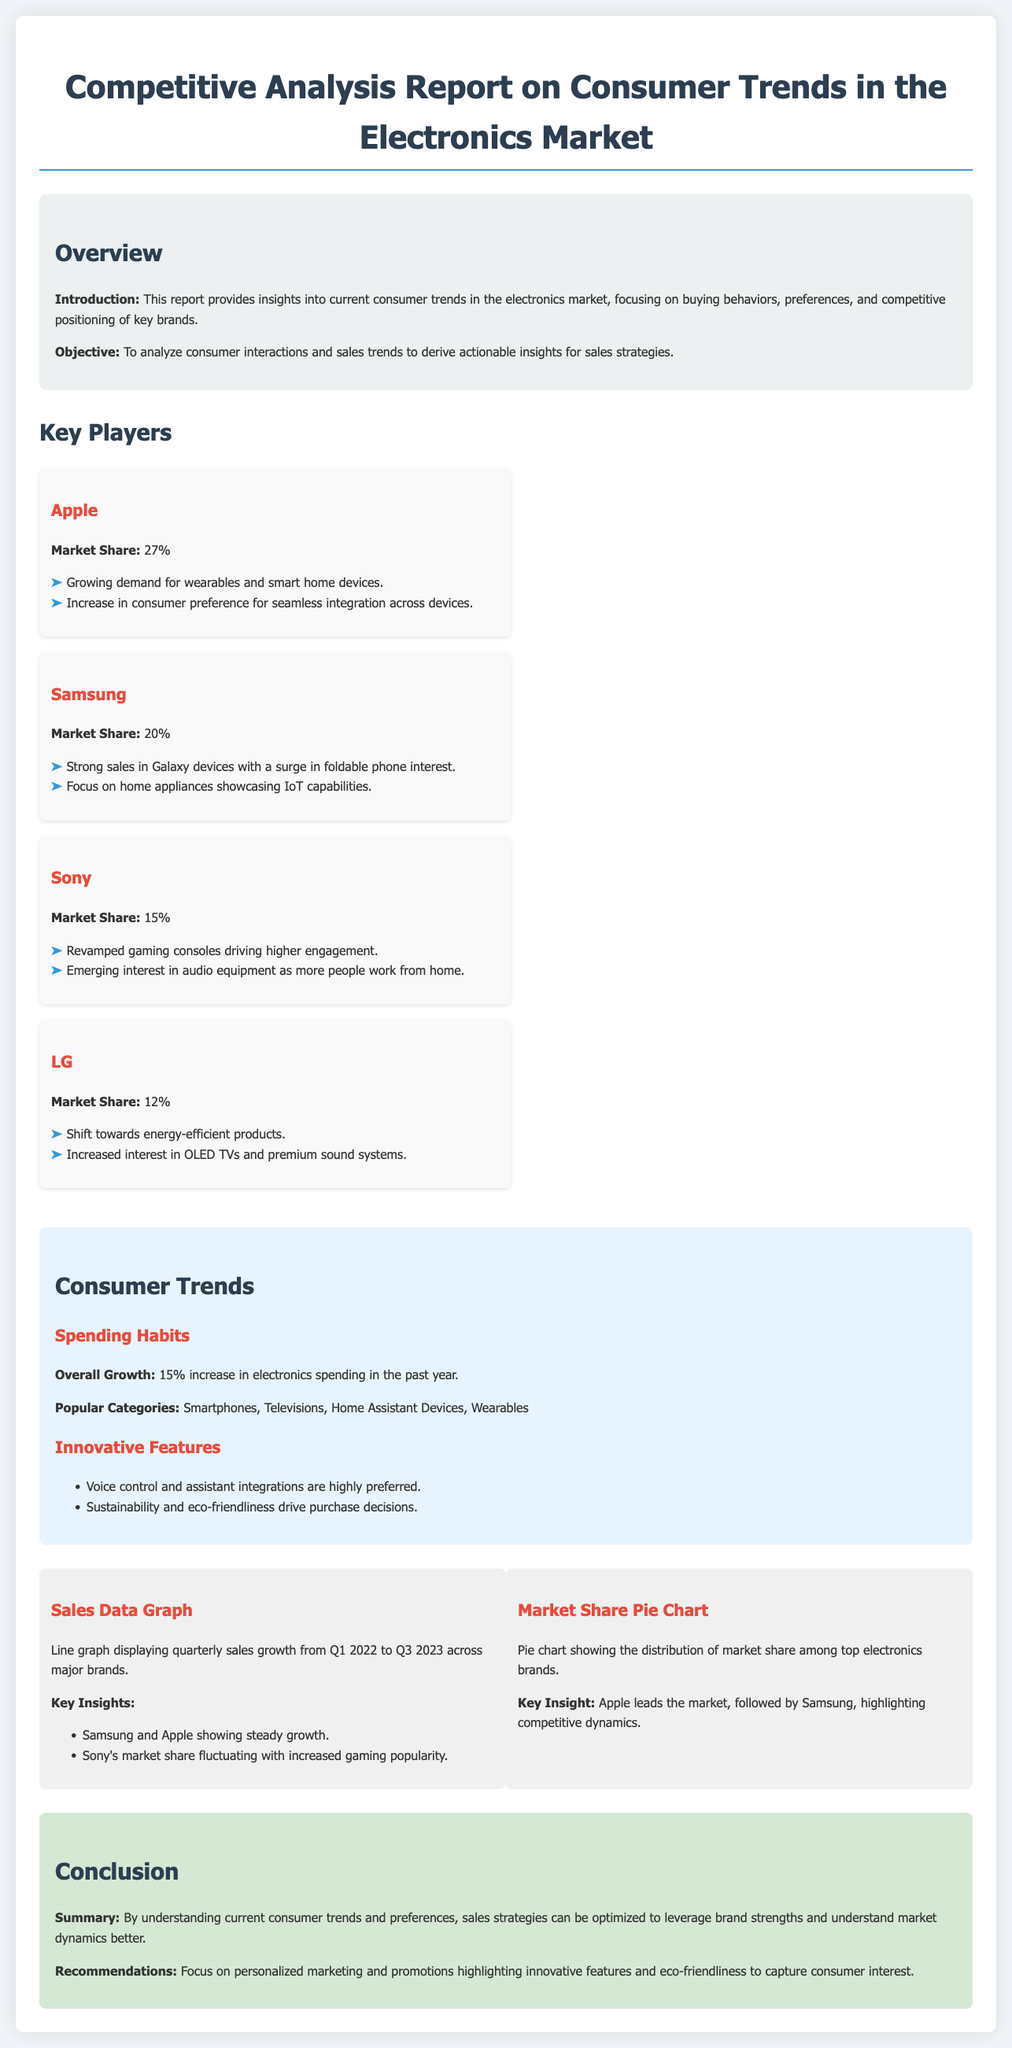What is the market share of Apple? The report states that Apple's market share is 27%.
Answer: 27% What trend is highlighted for Samsung? The report notes strong sales in Galaxy devices with a surge in foldable phone interest.
Answer: Foldable phone interest What is the overall growth in electronics spending? The document mentions a 15% increase in electronics spending in the past year.
Answer: 15% Which feature is highly preferred by consumers? The report indicates that voice control and assistant integrations are highly preferred.
Answer: Voice control What recommendation is made for sales strategies? The conclusion suggests focusing on personalized marketing and promotions highlighting innovative features and eco-friendliness.
Answer: Personalized marketing How much market share does Sony hold? The report specifies that Sony's market share is 15%.
Answer: 15% What is the background color of the overview section? The overview section is described as having a background color of #ecf0f1.
Answer: #ecf0f1 Which brands are showing steady growth according to the sales data graph? The document highlights that Samsung and Apple are showing steady growth.
Answer: Samsung and Apple 